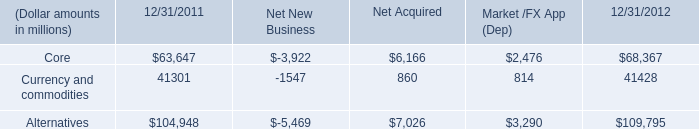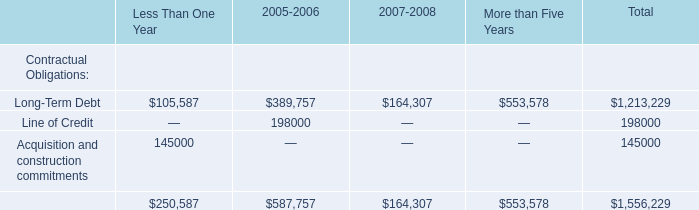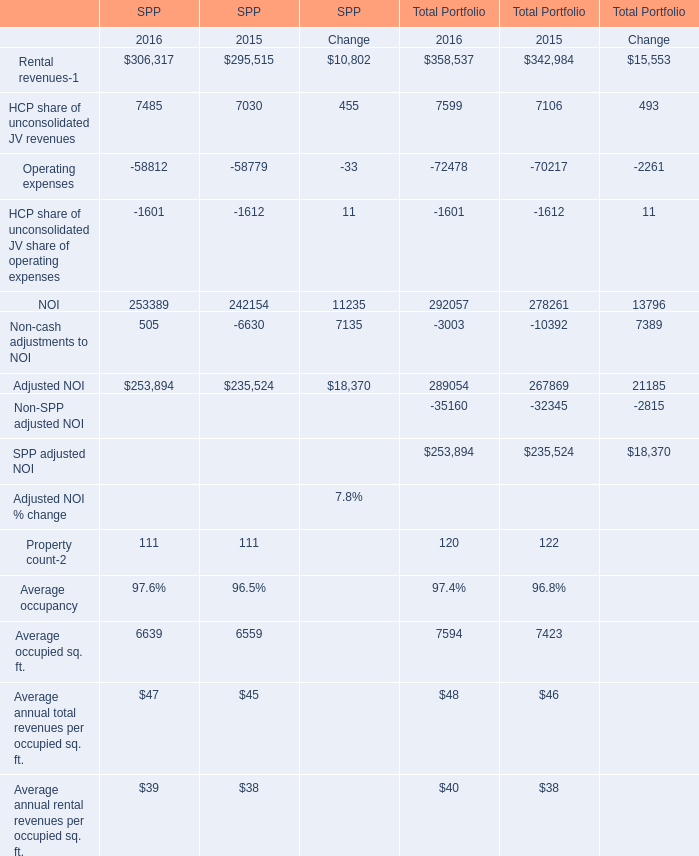What is the growing rate of Adjusted NOI in the years with the least NOI? 
Computations: (((253894 + 289054) - (235524 + 267869)) / (235524 + 267869))
Answer: 0.07858. 